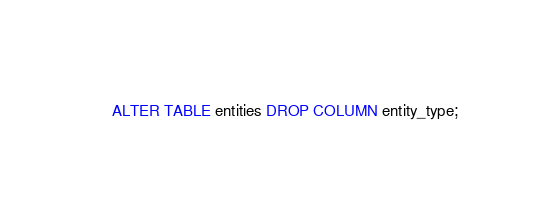<code> <loc_0><loc_0><loc_500><loc_500><_SQL_>ALTER TABLE entities DROP COLUMN entity_type;</code> 